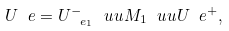Convert formula to latex. <formula><loc_0><loc_0><loc_500><loc_500>U _ { \ } e = U _ { \ e _ { 1 } } ^ { - } \ u u M _ { 1 } \ u u U _ { \ } e ^ { + } ,</formula> 